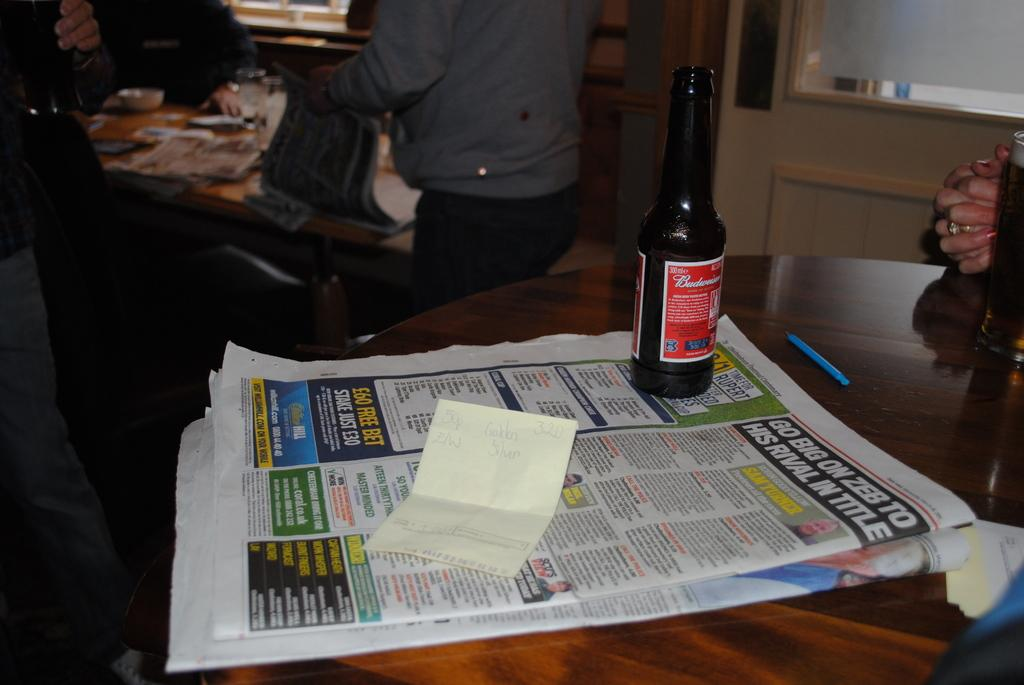How many bottles can be seen in the image? There are two bottles in the image. What else is on the table besides the bottles? There are papers on the table. Can you describe the person in the background? There is a person standing in the background. What other objects are on the table? There are objects on the table, but their specific details are not mentioned in the provided facts. What type of cave can be seen in the image? There is no cave present in the image. How does the person in the background use their sense of smell in the image? The person's sense of smell is not mentioned or depicted in the image. 